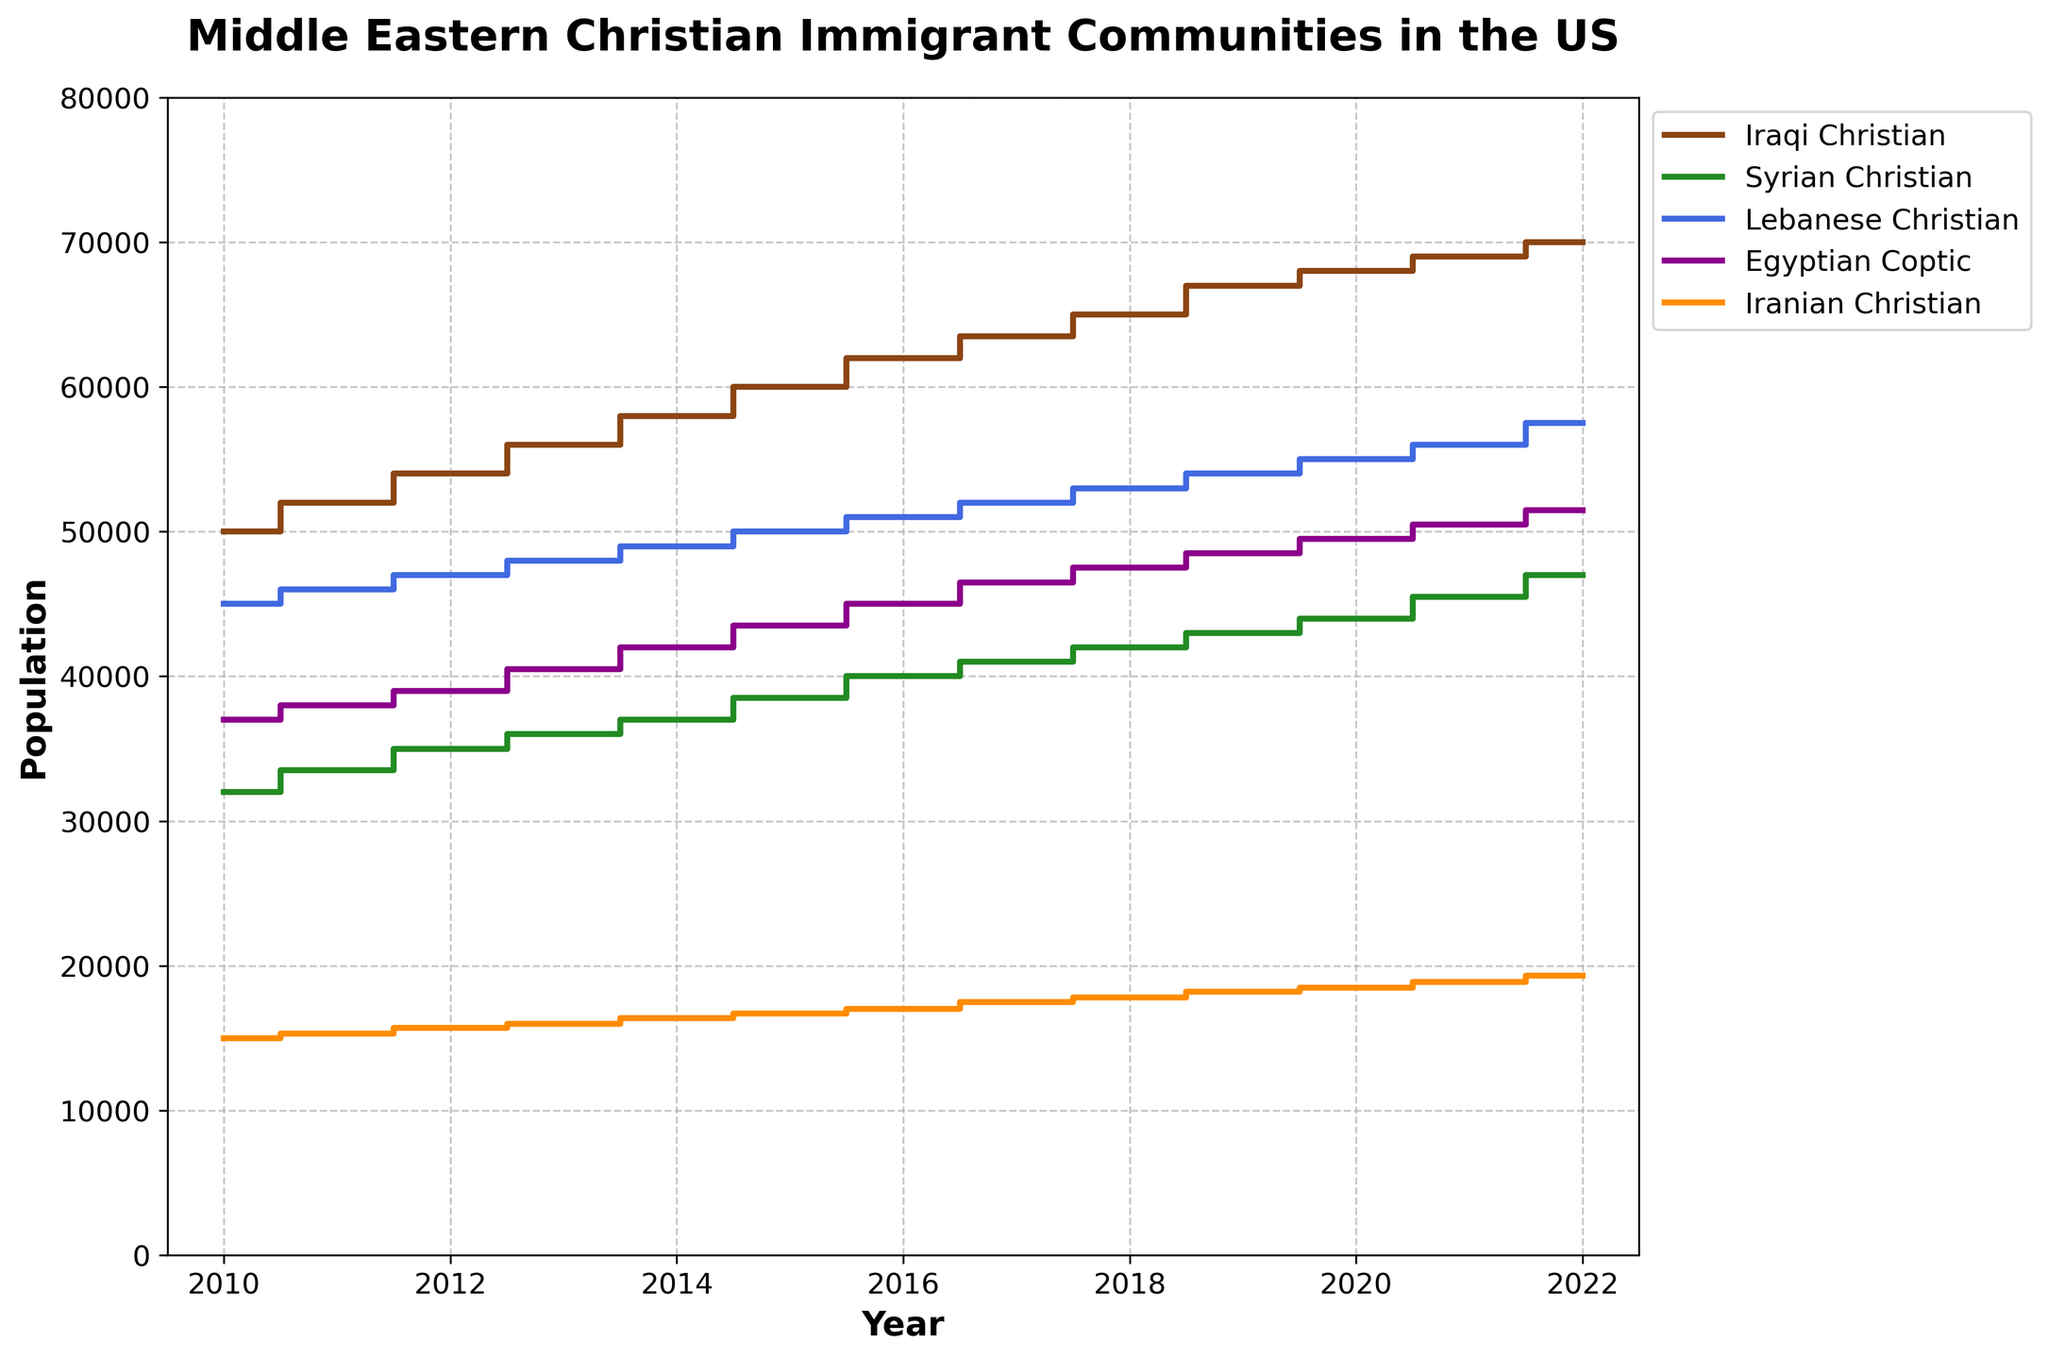What is the population of Iraqi Christian immigrants in the year 2018? Look for the data point corresponding to Iraqi Christian immigrants in the year 2018 as indicated on the x-axis.
Answer: 65000 What years show a population increase for Egyptian Coptic immigrants? Check the population data for Egyptian Coptic immigrants year-to-year and identify the years where there is an increase compared to the previous year.
Answer: Every year from 2010 to 2022 In which year did Lebanese Christian immigrants reach a population of 50000? Locate the data point where Lebanese Christian immigrants reach 50000 and note the corresponding year on the x-axis.
Answer: 2015 How much did the population of Iranian Christians grow between 2010 and 2022? Calculate the difference between the population of Iranian Christians in 2022 and 2010.
Answer: 4300 Which community had the largest population in 2020? Compare the population values of all communities in the year 2020 and identify the one with the highest value.
Answer: Iraqi Christian What is the average yearly increase in population for Syrian Christians from 2010 to 2022? Find the total increase in population for Syrian Christians from 2010 to 2022, then divide by the number of years.
Answer: (47000 - 32000) / 12 = 1250 What is the population difference between Lebanese Christian immigrants and Iranian Christian immigrants in 2012? Subtract the population of Iranian Christian immigrants in 2012 from that of Lebanese Christian immigrants.
Answer: 47000 - 15700 = 31300 Which immigrant community showed the most growth in numbers from 2010 to 2022? Calculate the total growth for each community by finding the difference between their populations in 2022 and 2010, then compare the results.
Answer: Iraqi Christian How many communities exceeded a population of 50000 by the year 2022? Count the number of communities with population values greater than 50000 in the year 2022.
Answer: Three Which year showed the highest growth rate for the Iraqi Christian immigrants? Find the year-over-year population change for Iraqi Christian immigrants and identify the year with the highest growth rate.
Answer: 2017 (1500 increase) 